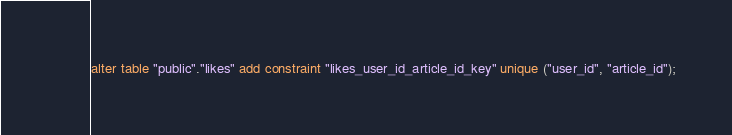Convert code to text. <code><loc_0><loc_0><loc_500><loc_500><_SQL_>alter table "public"."likes" add constraint "likes_user_id_article_id_key" unique ("user_id", "article_id");
</code> 